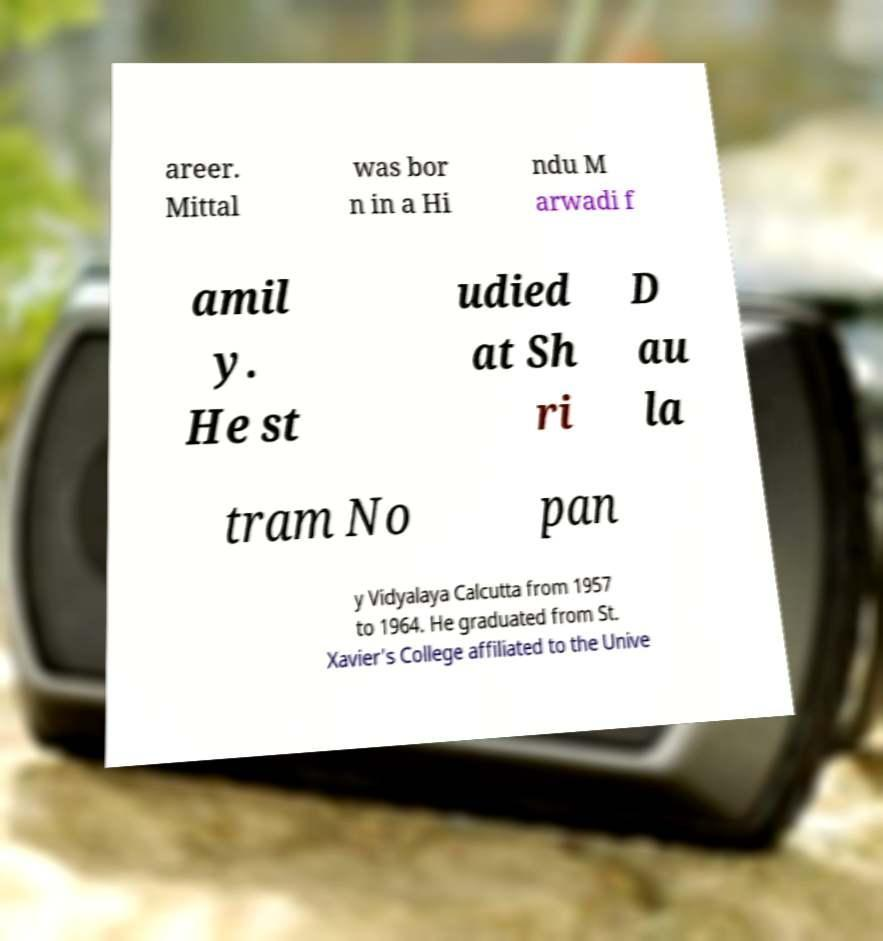For documentation purposes, I need the text within this image transcribed. Could you provide that? areer. Mittal was bor n in a Hi ndu M arwadi f amil y. He st udied at Sh ri D au la tram No pan y Vidyalaya Calcutta from 1957 to 1964. He graduated from St. Xavier's College affiliated to the Unive 